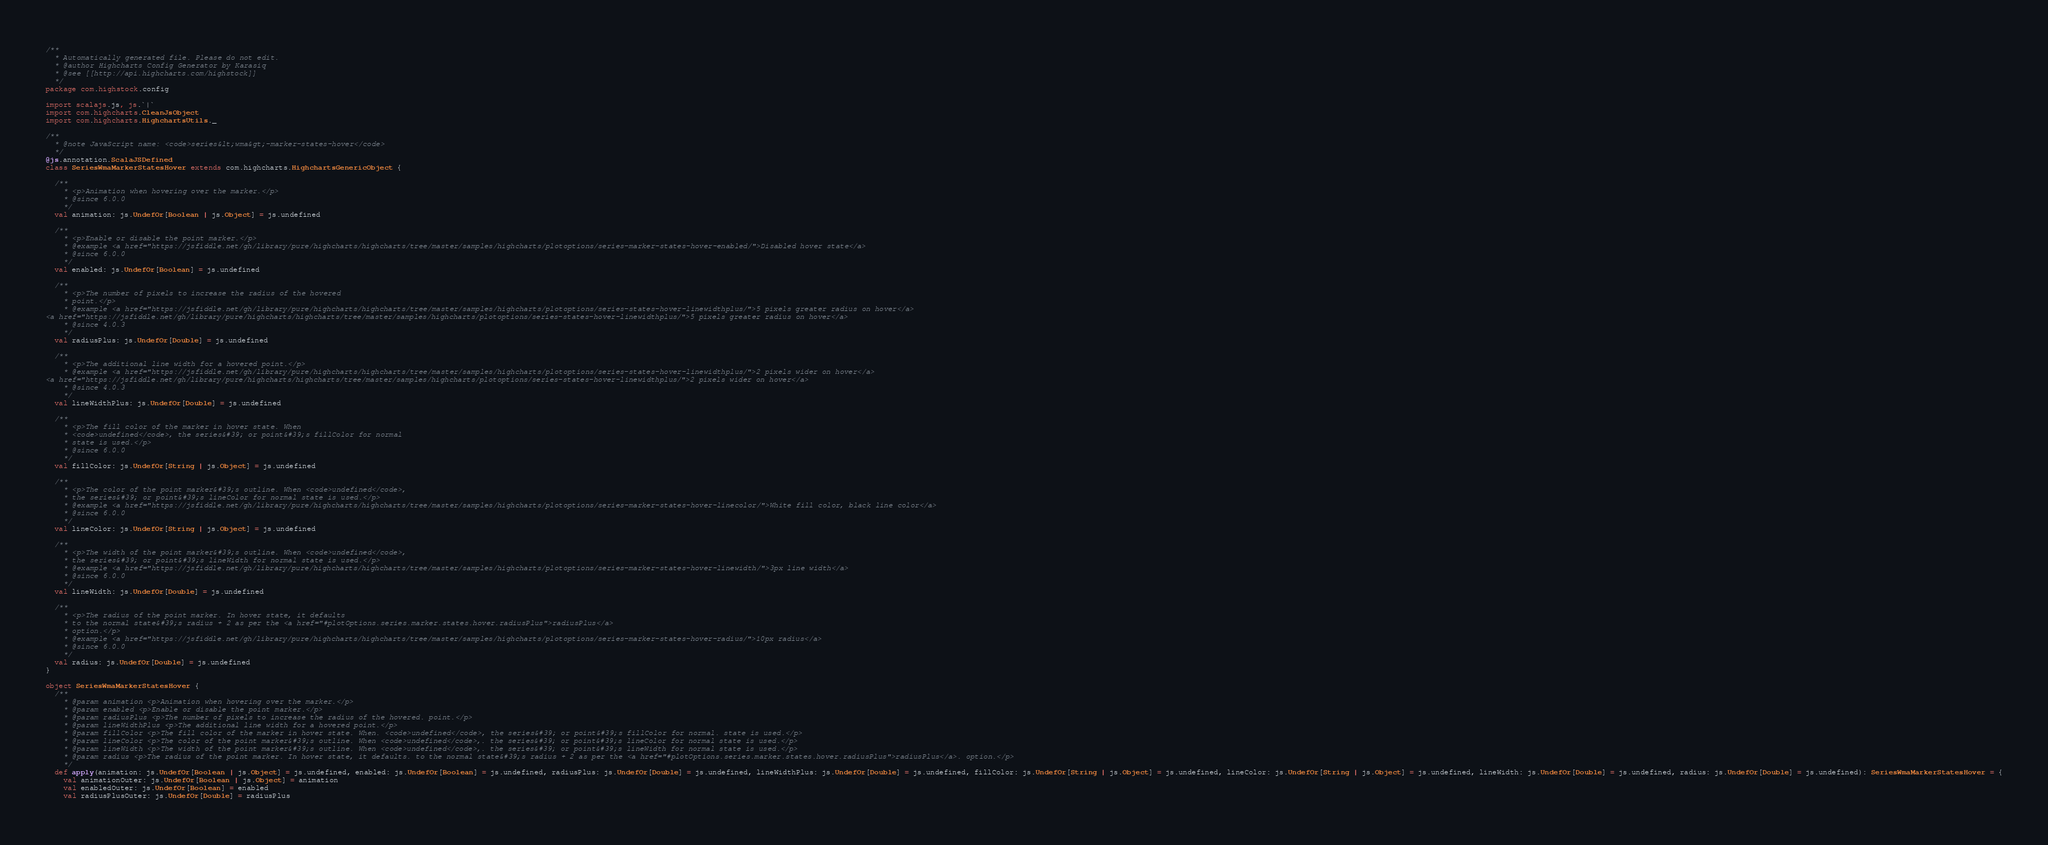Convert code to text. <code><loc_0><loc_0><loc_500><loc_500><_Scala_>/**
  * Automatically generated file. Please do not edit.
  * @author Highcharts Config Generator by Karasiq
  * @see [[http://api.highcharts.com/highstock]]
  */
package com.highstock.config

import scalajs.js, js.`|`
import com.highcharts.CleanJsObject
import com.highcharts.HighchartsUtils._

/**
  * @note JavaScript name: <code>series&lt;wma&gt;-marker-states-hover</code>
  */
@js.annotation.ScalaJSDefined
class SeriesWmaMarkerStatesHover extends com.highcharts.HighchartsGenericObject {

  /**
    * <p>Animation when hovering over the marker.</p>
    * @since 6.0.0
    */
  val animation: js.UndefOr[Boolean | js.Object] = js.undefined

  /**
    * <p>Enable or disable the point marker.</p>
    * @example <a href="https://jsfiddle.net/gh/library/pure/highcharts/highcharts/tree/master/samples/highcharts/plotoptions/series-marker-states-hover-enabled/">Disabled hover state</a>
    * @since 6.0.0
    */
  val enabled: js.UndefOr[Boolean] = js.undefined

  /**
    * <p>The number of pixels to increase the radius of the hovered
    * point.</p>
    * @example <a href="https://jsfiddle.net/gh/library/pure/highcharts/highcharts/tree/master/samples/highcharts/plotoptions/series-states-hover-linewidthplus/">5 pixels greater radius on hover</a>
<a href="https://jsfiddle.net/gh/library/pure/highcharts/highcharts/tree/master/samples/highcharts/plotoptions/series-states-hover-linewidthplus/">5 pixels greater radius on hover</a>
    * @since 4.0.3
    */
  val radiusPlus: js.UndefOr[Double] = js.undefined

  /**
    * <p>The additional line width for a hovered point.</p>
    * @example <a href="https://jsfiddle.net/gh/library/pure/highcharts/highcharts/tree/master/samples/highcharts/plotoptions/series-states-hover-linewidthplus/">2 pixels wider on hover</a>
<a href="https://jsfiddle.net/gh/library/pure/highcharts/highcharts/tree/master/samples/highcharts/plotoptions/series-states-hover-linewidthplus/">2 pixels wider on hover</a>
    * @since 4.0.3
    */
  val lineWidthPlus: js.UndefOr[Double] = js.undefined

  /**
    * <p>The fill color of the marker in hover state. When
    * <code>undefined</code>, the series&#39; or point&#39;s fillColor for normal
    * state is used.</p>
    * @since 6.0.0
    */
  val fillColor: js.UndefOr[String | js.Object] = js.undefined

  /**
    * <p>The color of the point marker&#39;s outline. When <code>undefined</code>,
    * the series&#39; or point&#39;s lineColor for normal state is used.</p>
    * @example <a href="https://jsfiddle.net/gh/library/pure/highcharts/highcharts/tree/master/samples/highcharts/plotoptions/series-marker-states-hover-linecolor/">White fill color, black line color</a>
    * @since 6.0.0
    */
  val lineColor: js.UndefOr[String | js.Object] = js.undefined

  /**
    * <p>The width of the point marker&#39;s outline. When <code>undefined</code>,
    * the series&#39; or point&#39;s lineWidth for normal state is used.</p>
    * @example <a href="https://jsfiddle.net/gh/library/pure/highcharts/highcharts/tree/master/samples/highcharts/plotoptions/series-marker-states-hover-linewidth/">3px line width</a>
    * @since 6.0.0
    */
  val lineWidth: js.UndefOr[Double] = js.undefined

  /**
    * <p>The radius of the point marker. In hover state, it defaults
    * to the normal state&#39;s radius + 2 as per the <a href="#plotOptions.series.marker.states.hover.radiusPlus">radiusPlus</a>
    * option.</p>
    * @example <a href="https://jsfiddle.net/gh/library/pure/highcharts/highcharts/tree/master/samples/highcharts/plotoptions/series-marker-states-hover-radius/">10px radius</a>
    * @since 6.0.0
    */
  val radius: js.UndefOr[Double] = js.undefined
}

object SeriesWmaMarkerStatesHover {
  /**
    * @param animation <p>Animation when hovering over the marker.</p>
    * @param enabled <p>Enable or disable the point marker.</p>
    * @param radiusPlus <p>The number of pixels to increase the radius of the hovered. point.</p>
    * @param lineWidthPlus <p>The additional line width for a hovered point.</p>
    * @param fillColor <p>The fill color of the marker in hover state. When. <code>undefined</code>, the series&#39; or point&#39;s fillColor for normal. state is used.</p>
    * @param lineColor <p>The color of the point marker&#39;s outline. When <code>undefined</code>,. the series&#39; or point&#39;s lineColor for normal state is used.</p>
    * @param lineWidth <p>The width of the point marker&#39;s outline. When <code>undefined</code>,. the series&#39; or point&#39;s lineWidth for normal state is used.</p>
    * @param radius <p>The radius of the point marker. In hover state, it defaults. to the normal state&#39;s radius + 2 as per the <a href="#plotOptions.series.marker.states.hover.radiusPlus">radiusPlus</a>. option.</p>
    */
  def apply(animation: js.UndefOr[Boolean | js.Object] = js.undefined, enabled: js.UndefOr[Boolean] = js.undefined, radiusPlus: js.UndefOr[Double] = js.undefined, lineWidthPlus: js.UndefOr[Double] = js.undefined, fillColor: js.UndefOr[String | js.Object] = js.undefined, lineColor: js.UndefOr[String | js.Object] = js.undefined, lineWidth: js.UndefOr[Double] = js.undefined, radius: js.UndefOr[Double] = js.undefined): SeriesWmaMarkerStatesHover = {
    val animationOuter: js.UndefOr[Boolean | js.Object] = animation
    val enabledOuter: js.UndefOr[Boolean] = enabled
    val radiusPlusOuter: js.UndefOr[Double] = radiusPlus</code> 